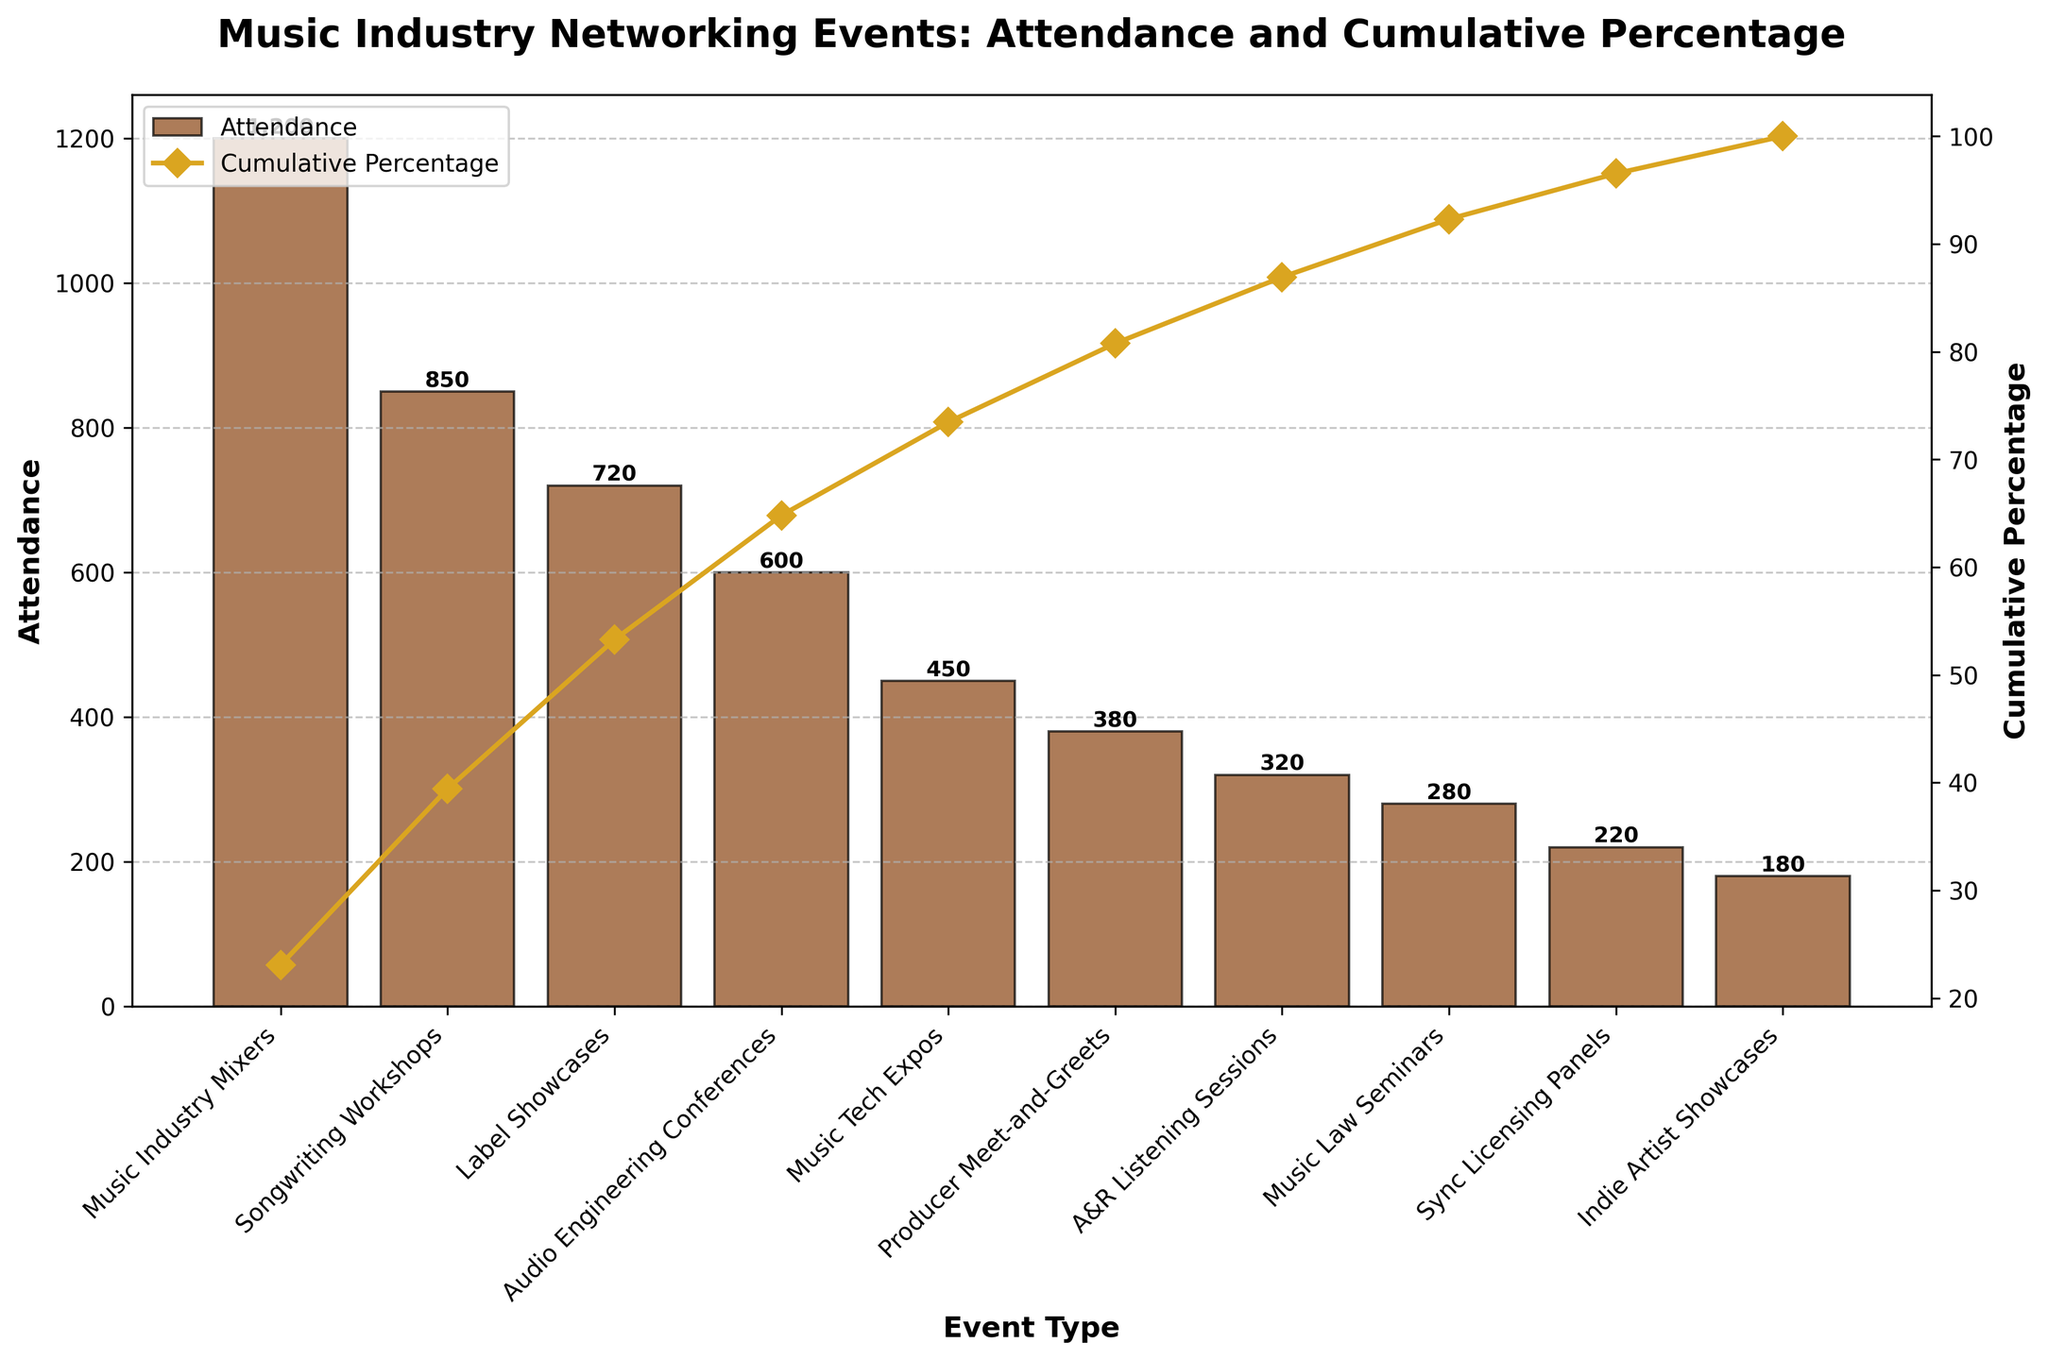what is the title of the figure? The title of the figure is displayed at the top and usually describes the content of the figure.
Answer: Music Industry Networking Events: Attendance and Cumulative Percentage which event type has the highest attendance? The highest attendance is represented by the tallest bar in the bar chart.
Answer: Music Industry Mixers what color are the bars representing attendance? The color of the bars is consistent throughout and can be seen visually in the figure.
Answer: brown how many event types are included in the figure? Counting the number of bars or categories on the x-axis will give the number of event types.
Answer: 10 what is the cumulative percentage after the first three event types? The cumulative percentage line chart shows the sum of percentages up to each event type. The first three event types are Music Industry Mixers, Songwriting Workshops, and Label Showcases. Adding their cumulative percentages provides the answer.
Answer: 64.6% which event has a cumulative percentage of just above 30%? The exact cumulative percentage values can be read from the line chart annotated with markers and labels.
Answer: Songwriting Workshops what's the difference in attendance between the highest and lowest attended events? Subtract the attendance of the lowest event (Indie Artist Showcases) from the highest event (Music Industry Mixers).
Answer: 1020 which two events have similar attendance numbers? Compare the heights of the bars to find two that are close in height, indicating similar attendance numbers.
Answer: A&R Listening Sessions and Music Law Seminars which event type adds the least to the cumulative percentage after including its attendance? The event type that adds the least to the cumulative percentage will be the last data point on the line chart with the smallest incremental change in the cumulative percentage.
Answer: Indie Artist Showcases what cumulative percentage does the A&R Listening Sessions event contribute to? Read the cumulative percentage value from the line chart where the A&R Listening Sessions event is marked.
Answer: 88.8% 